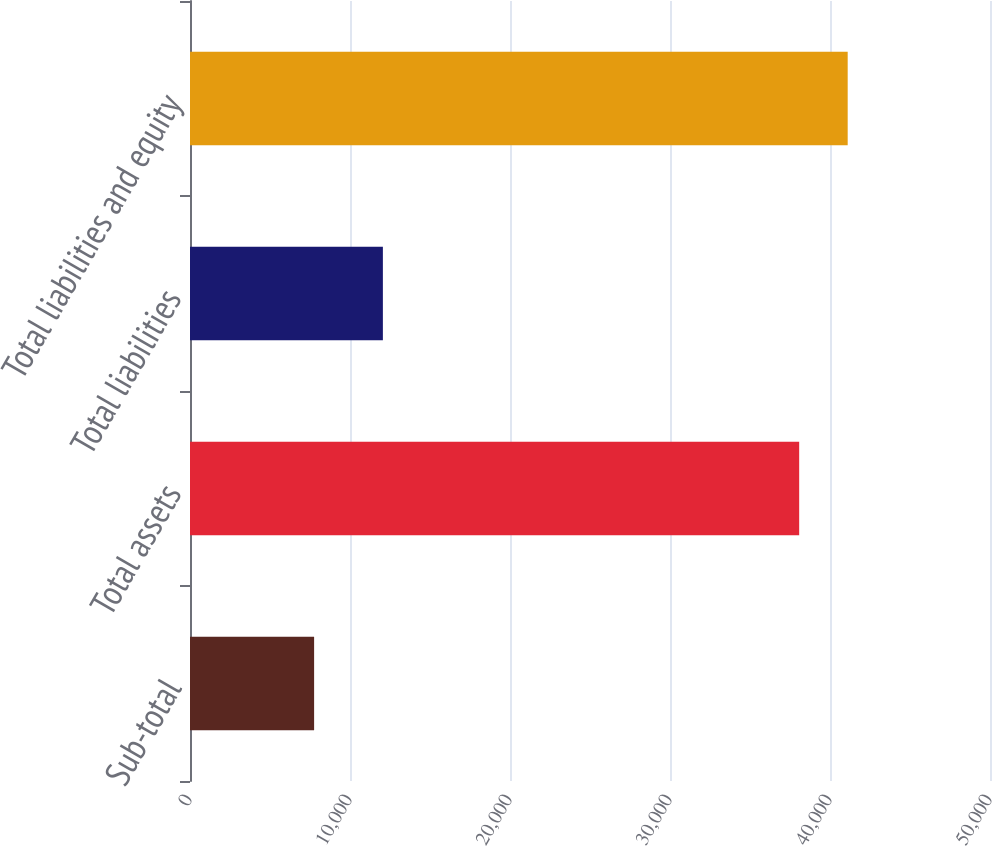<chart> <loc_0><loc_0><loc_500><loc_500><bar_chart><fcel>Sub-total<fcel>Total assets<fcel>Total liabilities<fcel>Total liabilities and equity<nl><fcel>7757<fcel>38074<fcel>12055<fcel>41105.7<nl></chart> 